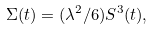Convert formula to latex. <formula><loc_0><loc_0><loc_500><loc_500>\Sigma ( t ) = ( \lambda ^ { 2 } / 6 ) S ^ { 3 } ( t ) ,</formula> 